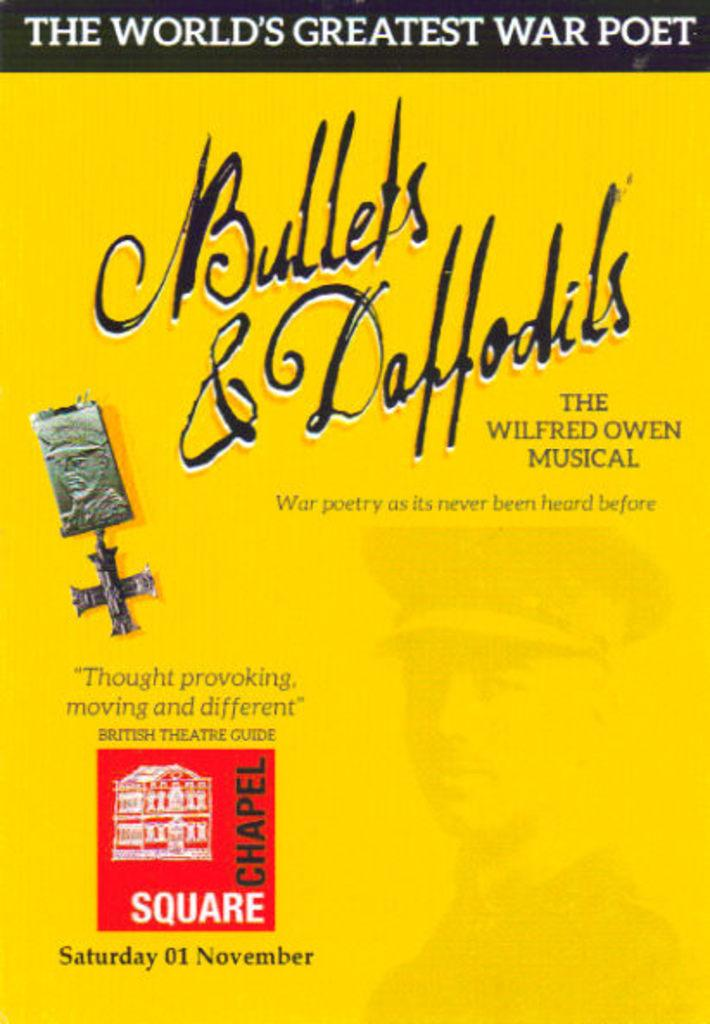<image>
Relay a brief, clear account of the picture shown. An advertisement for the musical Bullets & Daffodils on Saturday 01 November. 